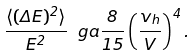<formula> <loc_0><loc_0><loc_500><loc_500>\frac { \langle ( \Delta E ) ^ { 2 } \rangle } { E ^ { 2 } } \ g a \frac { 8 } { 1 5 } \left ( \frac { v _ { h } } { V } \right ) ^ { 4 } .</formula> 